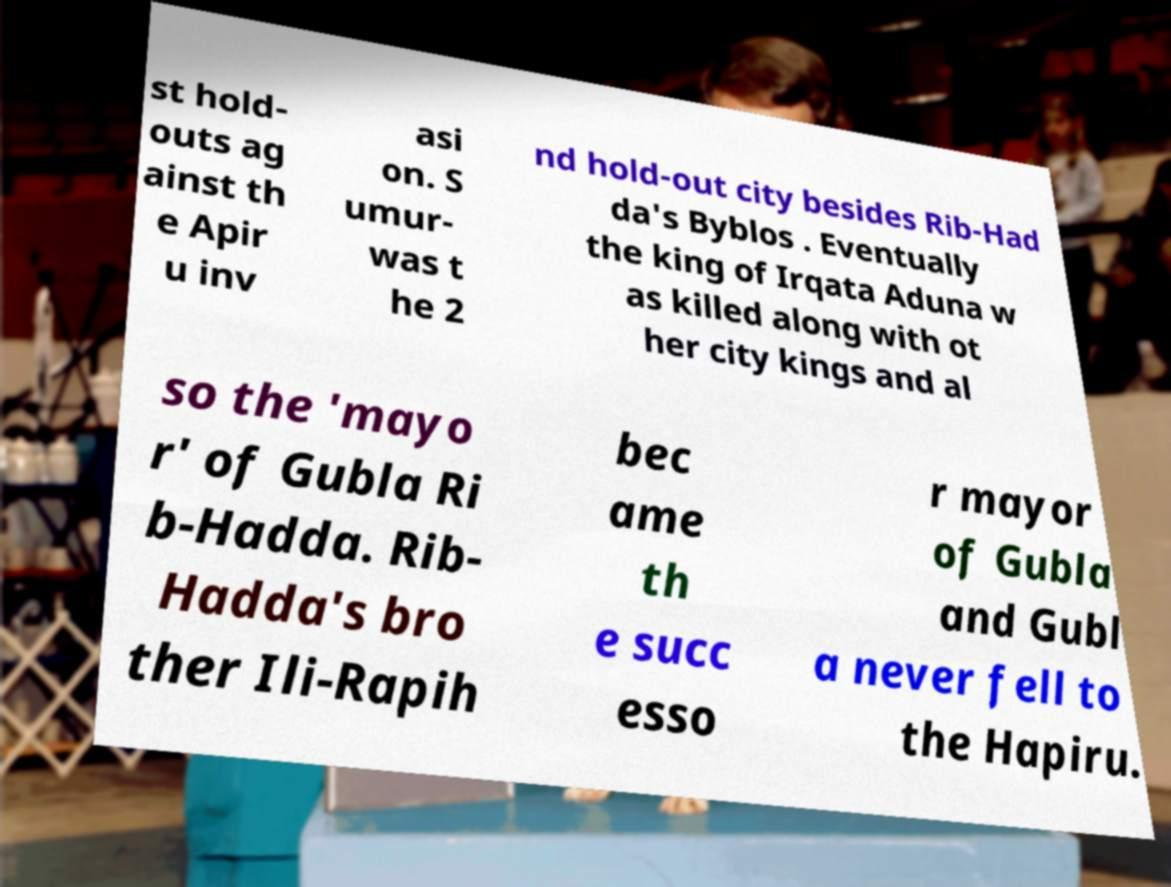Can you accurately transcribe the text from the provided image for me? st hold- outs ag ainst th e Apir u inv asi on. S umur- was t he 2 nd hold-out city besides Rib-Had da's Byblos . Eventually the king of Irqata Aduna w as killed along with ot her city kings and al so the 'mayo r' of Gubla Ri b-Hadda. Rib- Hadda's bro ther Ili-Rapih bec ame th e succ esso r mayor of Gubla and Gubl a never fell to the Hapiru. 